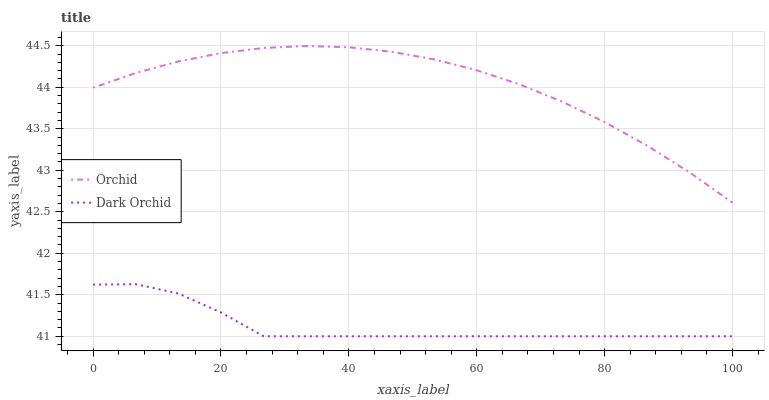Does Orchid have the minimum area under the curve?
Answer yes or no. No. Is Orchid the roughest?
Answer yes or no. No. Does Orchid have the lowest value?
Answer yes or no. No. Is Dark Orchid less than Orchid?
Answer yes or no. Yes. Is Orchid greater than Dark Orchid?
Answer yes or no. Yes. Does Dark Orchid intersect Orchid?
Answer yes or no. No. 